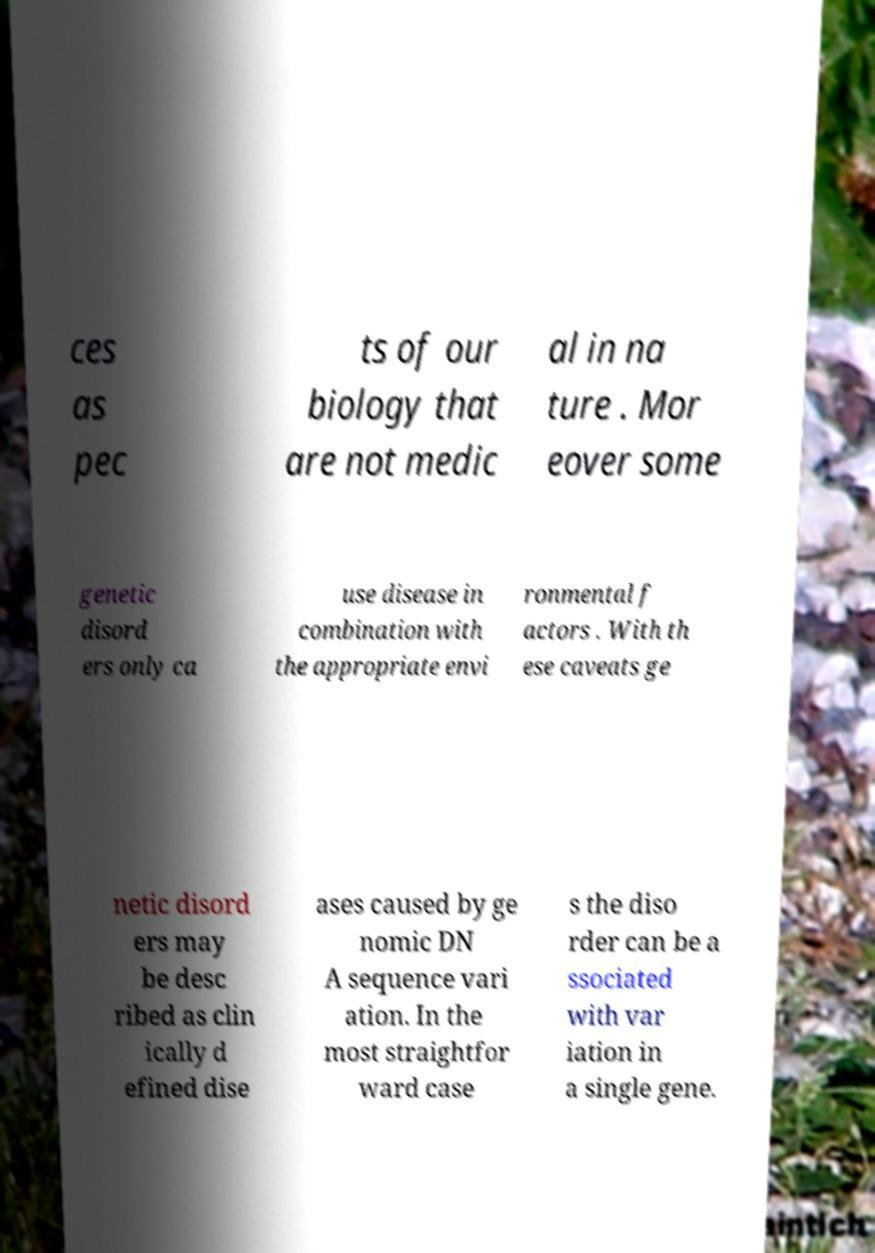Could you extract and type out the text from this image? ces as pec ts of our biology that are not medic al in na ture . Mor eover some genetic disord ers only ca use disease in combination with the appropriate envi ronmental f actors . With th ese caveats ge netic disord ers may be desc ribed as clin ically d efined dise ases caused by ge nomic DN A sequence vari ation. In the most straightfor ward case s the diso rder can be a ssociated with var iation in a single gene. 